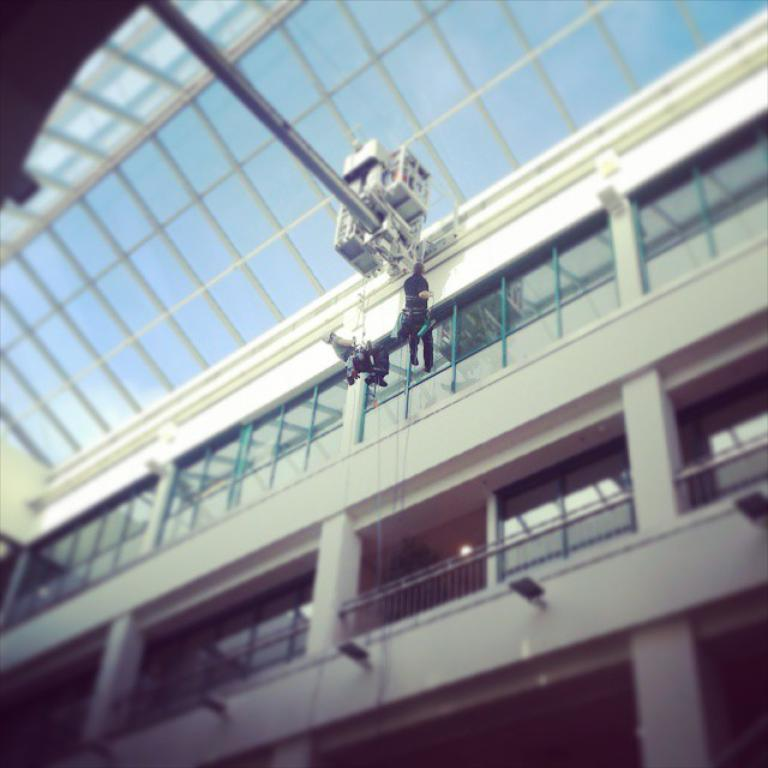What type of structure is present in the image? There is a building in the image. What features can be observed on the building? The building has windows, railings, and pillars. What else is present in the image besides the building? There is a pole with a machine and two persons hanging on ropes in the image. What type of lock is used on the doors of the building in the image? There is no information about locks on the doors of the building in the image. Can you tell me the profession of the lawyer in the image? There is no lawyer present in the image. 